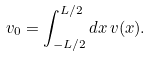Convert formula to latex. <formula><loc_0><loc_0><loc_500><loc_500>v _ { 0 } = \int _ { - L / 2 } ^ { L / 2 } d x \, v ( x ) .</formula> 